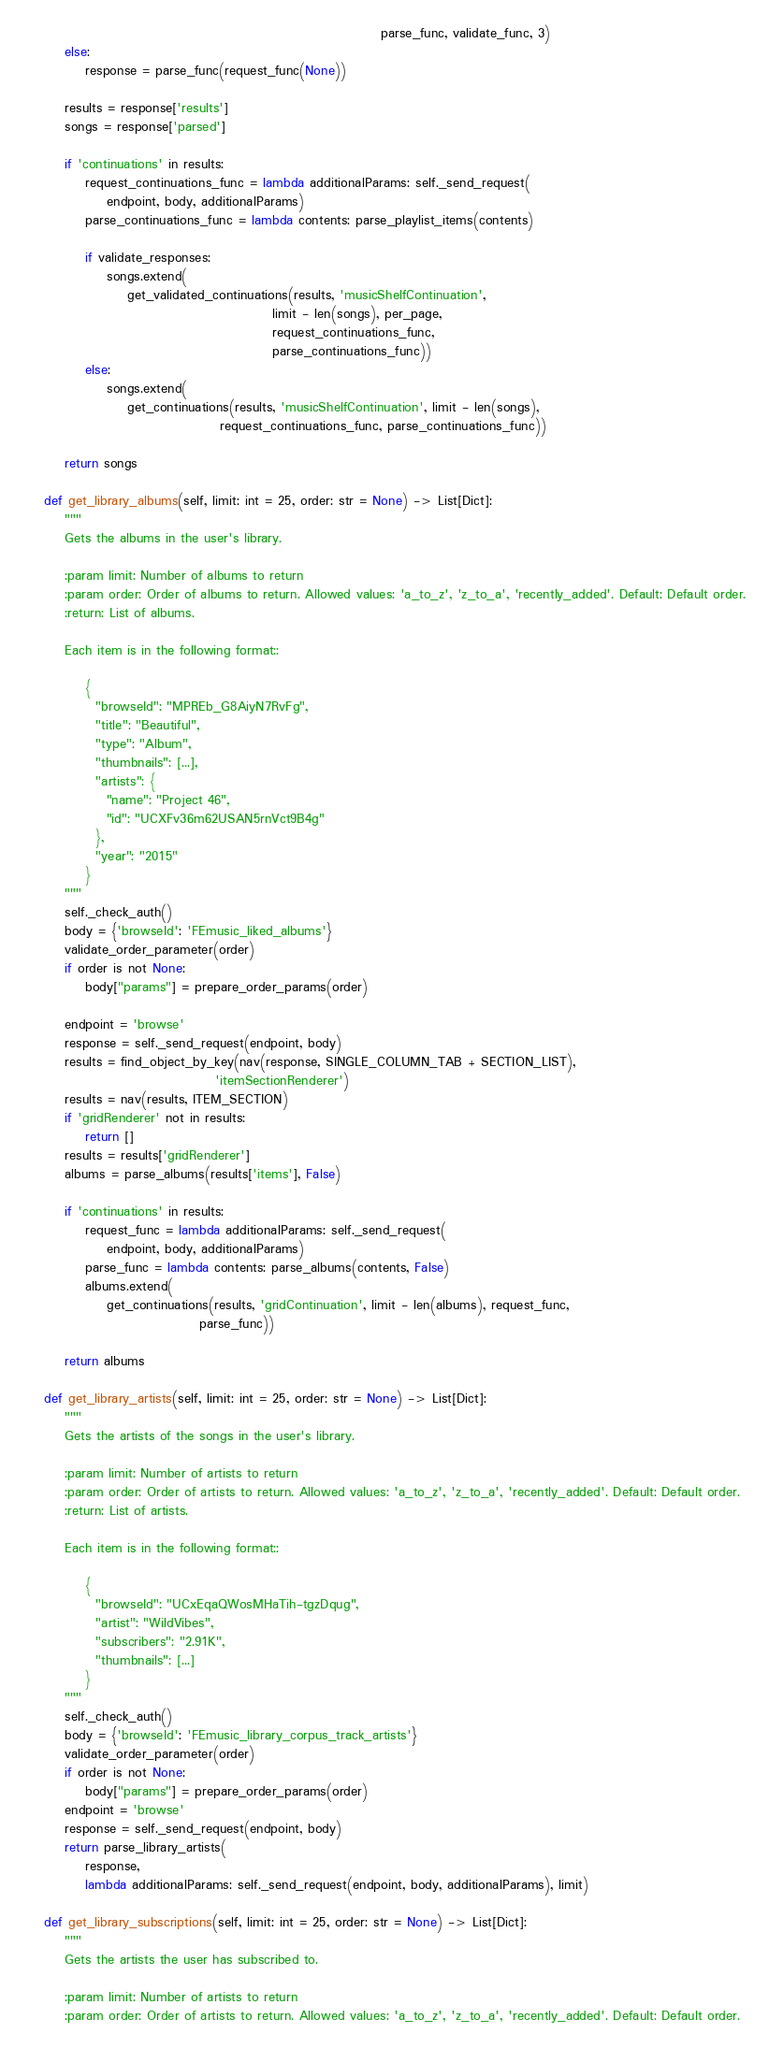Convert code to text. <code><loc_0><loc_0><loc_500><loc_500><_Python_>                                                                     parse_func, validate_func, 3)
        else:
            response = parse_func(request_func(None))

        results = response['results']
        songs = response['parsed']

        if 'continuations' in results:
            request_continuations_func = lambda additionalParams: self._send_request(
                endpoint, body, additionalParams)
            parse_continuations_func = lambda contents: parse_playlist_items(contents)

            if validate_responses:
                songs.extend(
                    get_validated_continuations(results, 'musicShelfContinuation',
                                                limit - len(songs), per_page,
                                                request_continuations_func,
                                                parse_continuations_func))
            else:
                songs.extend(
                    get_continuations(results, 'musicShelfContinuation', limit - len(songs),
                                      request_continuations_func, parse_continuations_func))

        return songs

    def get_library_albums(self, limit: int = 25, order: str = None) -> List[Dict]:
        """
        Gets the albums in the user's library.

        :param limit: Number of albums to return
        :param order: Order of albums to return. Allowed values: 'a_to_z', 'z_to_a', 'recently_added'. Default: Default order.
        :return: List of albums.

        Each item is in the following format::

            {
              "browseId": "MPREb_G8AiyN7RvFg",
              "title": "Beautiful",
              "type": "Album",
              "thumbnails": [...],
              "artists": {
                "name": "Project 46",
                "id": "UCXFv36m62USAN5rnVct9B4g"
              },
              "year": "2015"
            }
        """
        self._check_auth()
        body = {'browseId': 'FEmusic_liked_albums'}
        validate_order_parameter(order)
        if order is not None:
            body["params"] = prepare_order_params(order)

        endpoint = 'browse'
        response = self._send_request(endpoint, body)
        results = find_object_by_key(nav(response, SINGLE_COLUMN_TAB + SECTION_LIST),
                                     'itemSectionRenderer')
        results = nav(results, ITEM_SECTION)
        if 'gridRenderer' not in results:
            return []
        results = results['gridRenderer']
        albums = parse_albums(results['items'], False)

        if 'continuations' in results:
            request_func = lambda additionalParams: self._send_request(
                endpoint, body, additionalParams)
            parse_func = lambda contents: parse_albums(contents, False)
            albums.extend(
                get_continuations(results, 'gridContinuation', limit - len(albums), request_func,
                                  parse_func))

        return albums

    def get_library_artists(self, limit: int = 25, order: str = None) -> List[Dict]:
        """
        Gets the artists of the songs in the user's library.

        :param limit: Number of artists to return
        :param order: Order of artists to return. Allowed values: 'a_to_z', 'z_to_a', 'recently_added'. Default: Default order.
        :return: List of artists.

        Each item is in the following format::

            {
              "browseId": "UCxEqaQWosMHaTih-tgzDqug",
              "artist": "WildVibes",
              "subscribers": "2.91K",
              "thumbnails": [...]
            }
        """
        self._check_auth()
        body = {'browseId': 'FEmusic_library_corpus_track_artists'}
        validate_order_parameter(order)
        if order is not None:
            body["params"] = prepare_order_params(order)
        endpoint = 'browse'
        response = self._send_request(endpoint, body)
        return parse_library_artists(
            response,
            lambda additionalParams: self._send_request(endpoint, body, additionalParams), limit)

    def get_library_subscriptions(self, limit: int = 25, order: str = None) -> List[Dict]:
        """
        Gets the artists the user has subscribed to.

        :param limit: Number of artists to return
        :param order: Order of artists to return. Allowed values: 'a_to_z', 'z_to_a', 'recently_added'. Default: Default order.</code> 